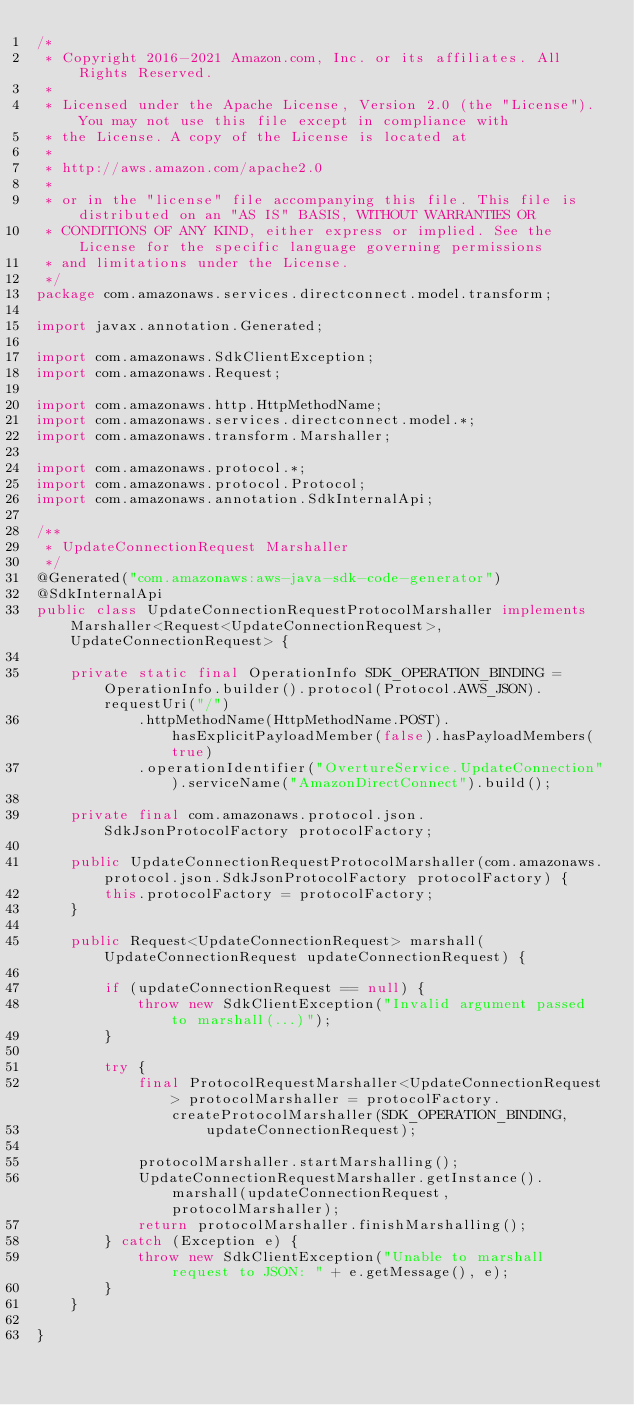Convert code to text. <code><loc_0><loc_0><loc_500><loc_500><_Java_>/*
 * Copyright 2016-2021 Amazon.com, Inc. or its affiliates. All Rights Reserved.
 * 
 * Licensed under the Apache License, Version 2.0 (the "License"). You may not use this file except in compliance with
 * the License. A copy of the License is located at
 * 
 * http://aws.amazon.com/apache2.0
 * 
 * or in the "license" file accompanying this file. This file is distributed on an "AS IS" BASIS, WITHOUT WARRANTIES OR
 * CONDITIONS OF ANY KIND, either express or implied. See the License for the specific language governing permissions
 * and limitations under the License.
 */
package com.amazonaws.services.directconnect.model.transform;

import javax.annotation.Generated;

import com.amazonaws.SdkClientException;
import com.amazonaws.Request;

import com.amazonaws.http.HttpMethodName;
import com.amazonaws.services.directconnect.model.*;
import com.amazonaws.transform.Marshaller;

import com.amazonaws.protocol.*;
import com.amazonaws.protocol.Protocol;
import com.amazonaws.annotation.SdkInternalApi;

/**
 * UpdateConnectionRequest Marshaller
 */
@Generated("com.amazonaws:aws-java-sdk-code-generator")
@SdkInternalApi
public class UpdateConnectionRequestProtocolMarshaller implements Marshaller<Request<UpdateConnectionRequest>, UpdateConnectionRequest> {

    private static final OperationInfo SDK_OPERATION_BINDING = OperationInfo.builder().protocol(Protocol.AWS_JSON).requestUri("/")
            .httpMethodName(HttpMethodName.POST).hasExplicitPayloadMember(false).hasPayloadMembers(true)
            .operationIdentifier("OvertureService.UpdateConnection").serviceName("AmazonDirectConnect").build();

    private final com.amazonaws.protocol.json.SdkJsonProtocolFactory protocolFactory;

    public UpdateConnectionRequestProtocolMarshaller(com.amazonaws.protocol.json.SdkJsonProtocolFactory protocolFactory) {
        this.protocolFactory = protocolFactory;
    }

    public Request<UpdateConnectionRequest> marshall(UpdateConnectionRequest updateConnectionRequest) {

        if (updateConnectionRequest == null) {
            throw new SdkClientException("Invalid argument passed to marshall(...)");
        }

        try {
            final ProtocolRequestMarshaller<UpdateConnectionRequest> protocolMarshaller = protocolFactory.createProtocolMarshaller(SDK_OPERATION_BINDING,
                    updateConnectionRequest);

            protocolMarshaller.startMarshalling();
            UpdateConnectionRequestMarshaller.getInstance().marshall(updateConnectionRequest, protocolMarshaller);
            return protocolMarshaller.finishMarshalling();
        } catch (Exception e) {
            throw new SdkClientException("Unable to marshall request to JSON: " + e.getMessage(), e);
        }
    }

}
</code> 